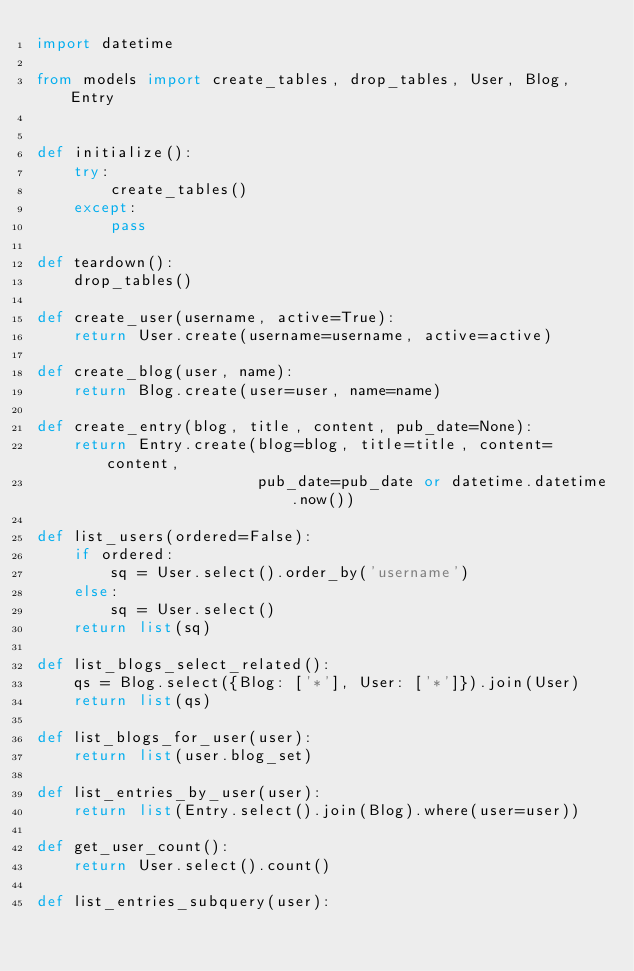Convert code to text. <code><loc_0><loc_0><loc_500><loc_500><_Python_>import datetime

from models import create_tables, drop_tables, User, Blog, Entry


def initialize():
    try:
        create_tables()
    except:
        pass

def teardown():
    drop_tables()

def create_user(username, active=True):
    return User.create(username=username, active=active)

def create_blog(user, name):
    return Blog.create(user=user, name=name)

def create_entry(blog, title, content, pub_date=None):
    return Entry.create(blog=blog, title=title, content=content,
                        pub_date=pub_date or datetime.datetime.now())

def list_users(ordered=False):
    if ordered:
        sq = User.select().order_by('username')
    else:
        sq = User.select()
    return list(sq)

def list_blogs_select_related():
    qs = Blog.select({Blog: ['*'], User: ['*']}).join(User)
    return list(qs)

def list_blogs_for_user(user):
    return list(user.blog_set)

def list_entries_by_user(user):
    return list(Entry.select().join(Blog).where(user=user))

def get_user_count():
    return User.select().count()

def list_entries_subquery(user):</code> 